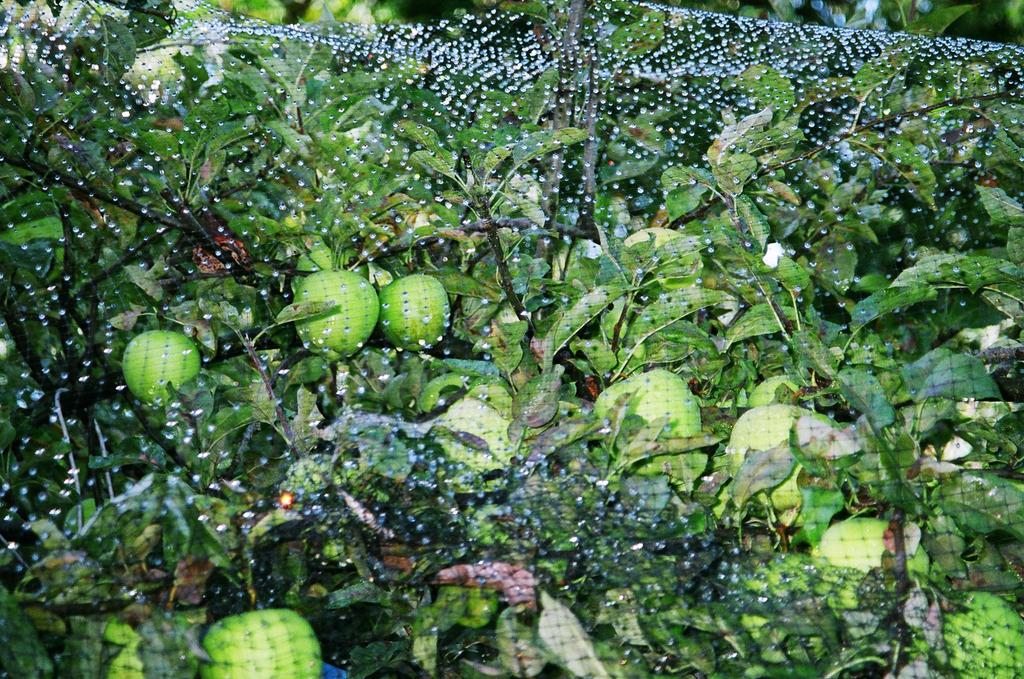What type of plants can be seen in the image? There are plants with fruits in the image. What additional object is present in the image? There is a net in the image. How many balls are visible in the image? There are no balls present in the image. What is the position of the moon in the image? There is no moon visible in the image. 